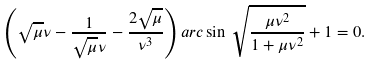Convert formula to latex. <formula><loc_0><loc_0><loc_500><loc_500>\left ( \sqrt { \mu } \nu - \frac { 1 } { \sqrt { \mu } \nu } - \frac { 2 \sqrt { \mu } } { \nu ^ { 3 } } \right ) a r c \sin \, \sqrt { \frac { \mu \nu ^ { 2 } } { 1 + \mu \nu ^ { 2 } } } + 1 = 0 .</formula> 